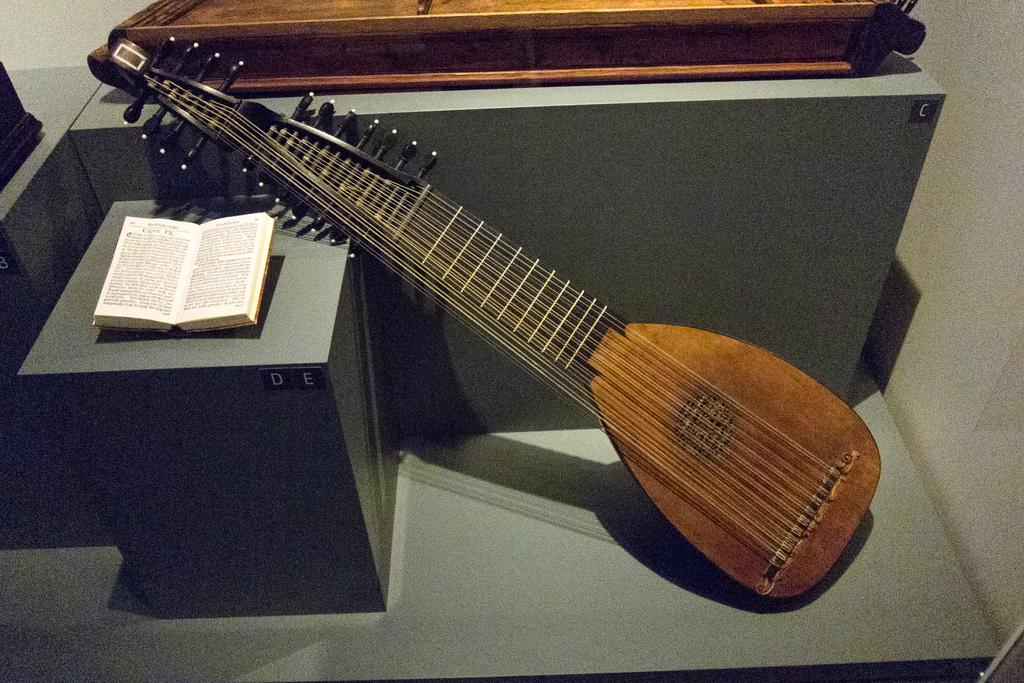What type of object is the main subject in the image? There is a musical instrument in the image. What other object can be seen in the image? There is a book in the image. Can you describe the positioning of an object in the image? There is an object on a platform in the image. How many dolls are sitting on the musical instrument in the image? There are no dolls present in the image. 